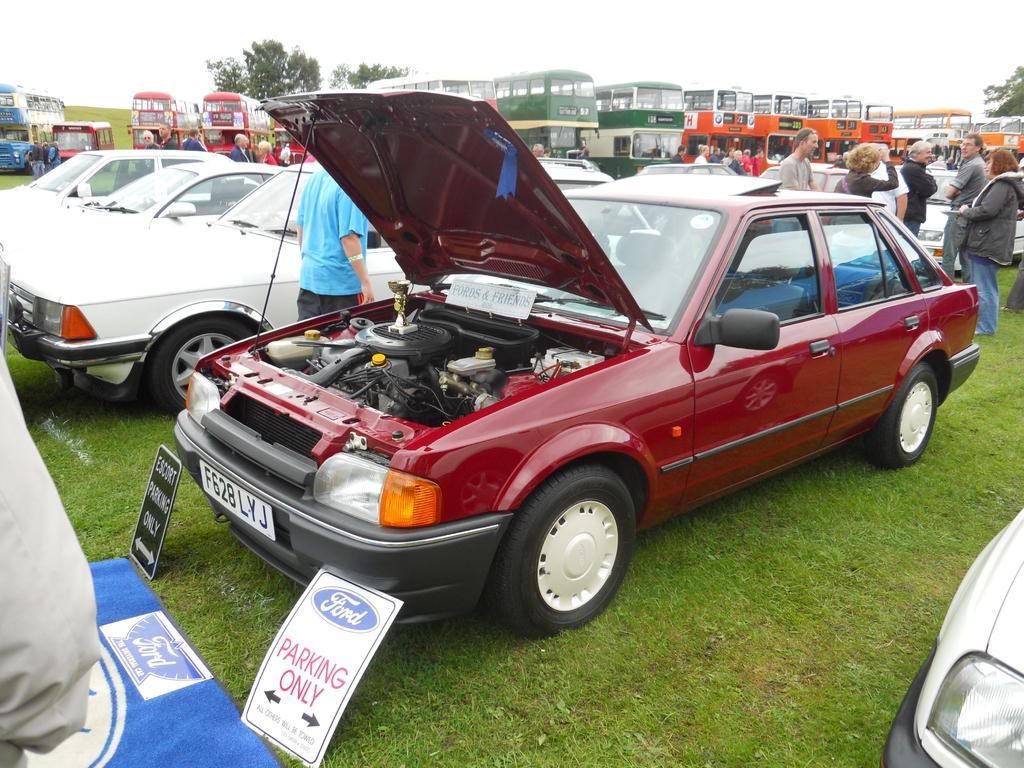How would you summarize this image in a sentence or two? In this picture there is a red color car with open bonnet is parked in the ground. Beside there are three white color cars. Behind there are many double Decker buses standing beside each other. On the right side there is a group of men and women doing the inspection of the cars. 